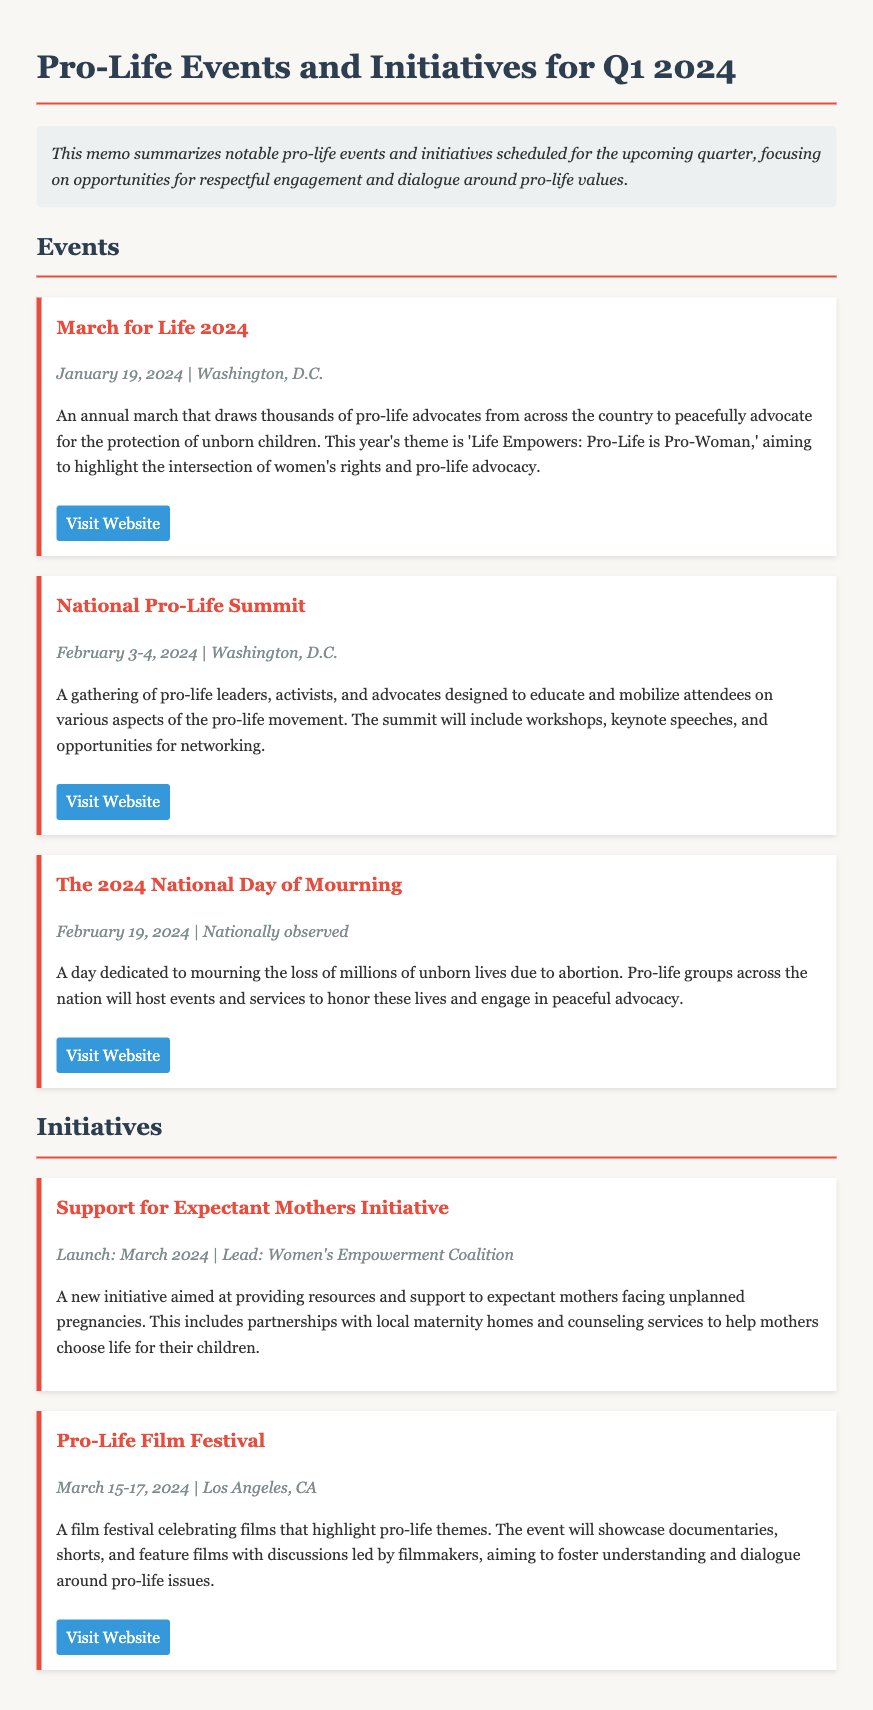What is the date of the March for Life 2024? The date of the March for Life 2024 is specifically mentioned in the document.
Answer: January 19, 2024 What is the theme of the March for Life 2024? The theme is stated in the description of the event, reflecting the focus of the advocacy.
Answer: Life Empowers: Pro-Life is Pro-Woman When is the National Pro-Life Summit? The National Pro-Life Summit's dates are provided in the document, indicating when it will occur.
Answer: February 3-4, 2024 Which organization leads the Support for Expectant Mothers Initiative? The leading organization for the initiative is specified in the document, highlighting key stakeholders.
Answer: Women's Empowerment Coalition What is the focus of the Pro-Life Film Festival? The focus is mentioned in the description of the initiative, defining the theme of the festival.
Answer: Celebrating films that highlight pro-life themes How many days is the Pro-Life Film Festival scheduled to last? The duration of the festival can be calculated based on the provided start and end dates.
Answer: 3 days On which date is The 2024 National Day of Mourning observed? The date for The 2024 National Day of Mourning is outlined in the event section.
Answer: February 19, 2024 What type of events will be organized on The 2024 National Day of Mourning? The description indicates the nature of the activities planned for the day.
Answer: Events and services 